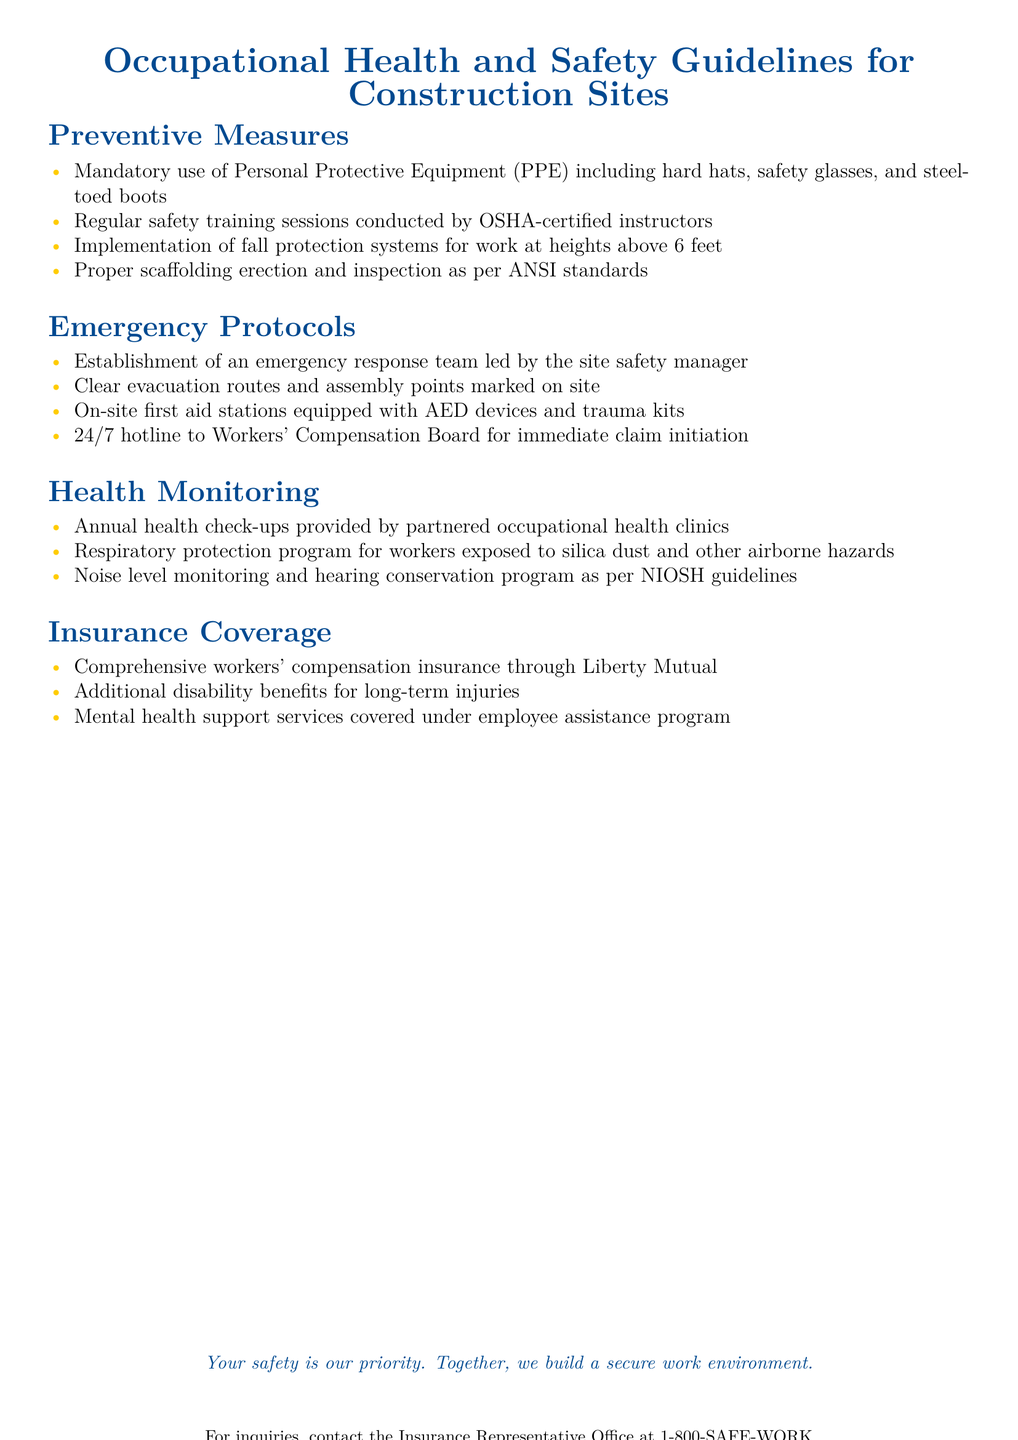What is the required PPE for construction workers? The document states that mandatory use of personal protective equipment includes hard hats, safety glasses, and steel-toed boots.
Answer: hard hats, safety glasses, steel-toed boots How often are safety training sessions conducted? The document mentions that regular safety training sessions are conducted, but does not specify a frequency.
Answer: Regularly What is the height threshold for fall protection systems? The document specifies that fall protection systems are implemented for work at heights above 6 feet.
Answer: 6 feet Who leads the emergency response team? According to the document, the emergency response team is led by the site safety manager.
Answer: Site safety manager What type of insurance is provided for workers? The document states that comprehensive workers' compensation insurance is provided through Liberty Mutual.
Answer: Liberty Mutual What equipment is available at on-site first aid stations? The document lists that on-site first aid stations are equipped with AED devices and trauma kits.
Answer: AED devices, trauma kits What program is in place for respiratory protection? The document mentions a respiratory protection program for workers exposed to silica dust and other airborne hazards.
Answer: Respiratory protection program How many health check-ups are provided annually? The document specifies that annual health check-ups are provided by partnered occupational health clinics.
Answer: Annual health check-ups What additional support is covered under the employee assistance program? The document states that mental health support services are covered under the employee assistance program.
Answer: Mental health support services 